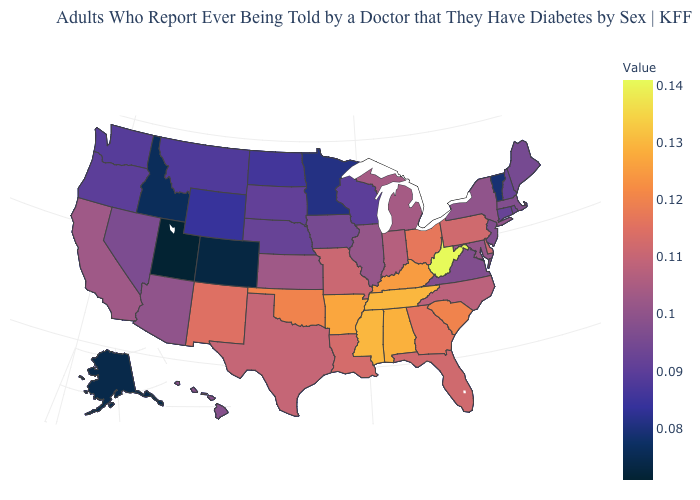Is the legend a continuous bar?
Keep it brief. Yes. Among the states that border Wyoming , does Nebraska have the highest value?
Answer briefly. Yes. Does the map have missing data?
Concise answer only. No. Among the states that border Missouri , does Tennessee have the highest value?
Give a very brief answer. Yes. Does South Dakota have the lowest value in the MidWest?
Short answer required. No. Does the map have missing data?
Quick response, please. No. 